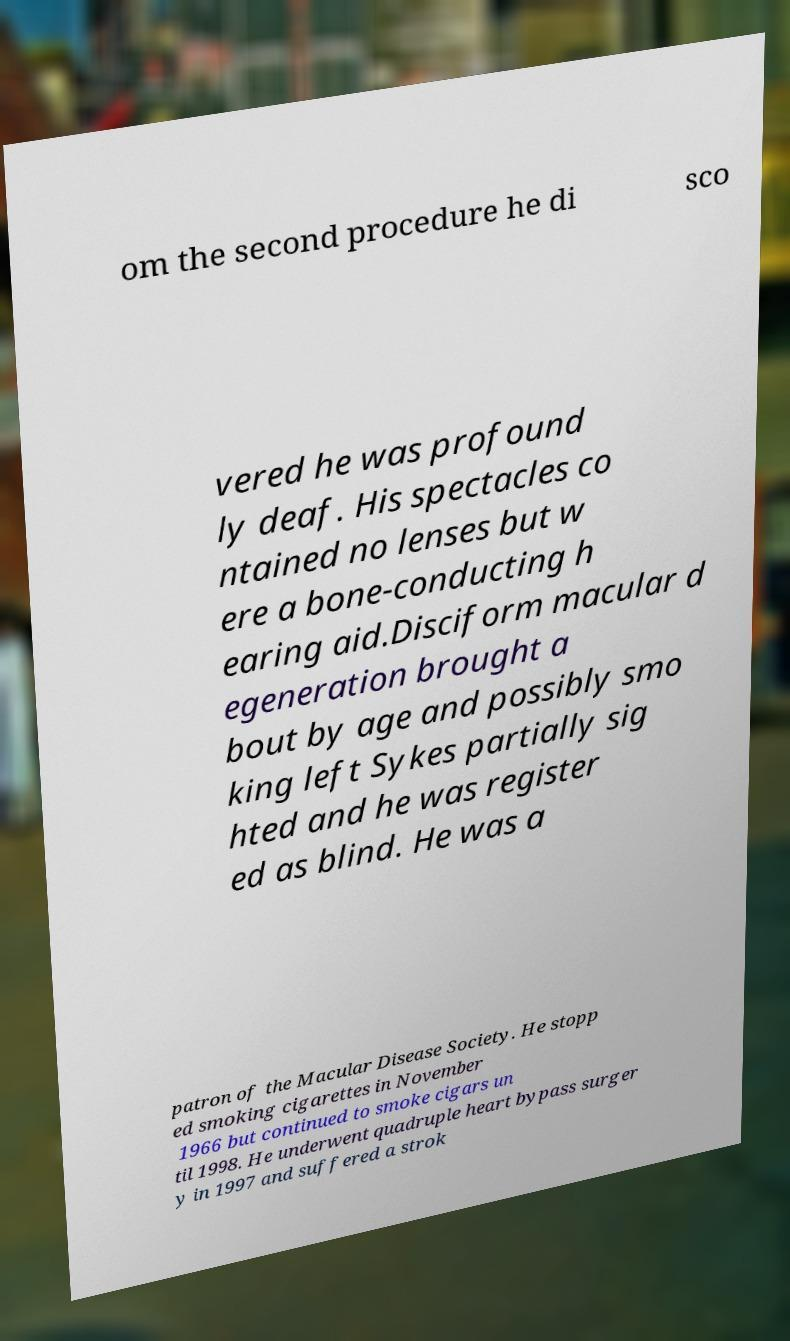Please identify and transcribe the text found in this image. om the second procedure he di sco vered he was profound ly deaf. His spectacles co ntained no lenses but w ere a bone-conducting h earing aid.Disciform macular d egeneration brought a bout by age and possibly smo king left Sykes partially sig hted and he was register ed as blind. He was a patron of the Macular Disease Society. He stopp ed smoking cigarettes in November 1966 but continued to smoke cigars un til 1998. He underwent quadruple heart bypass surger y in 1997 and suffered a strok 